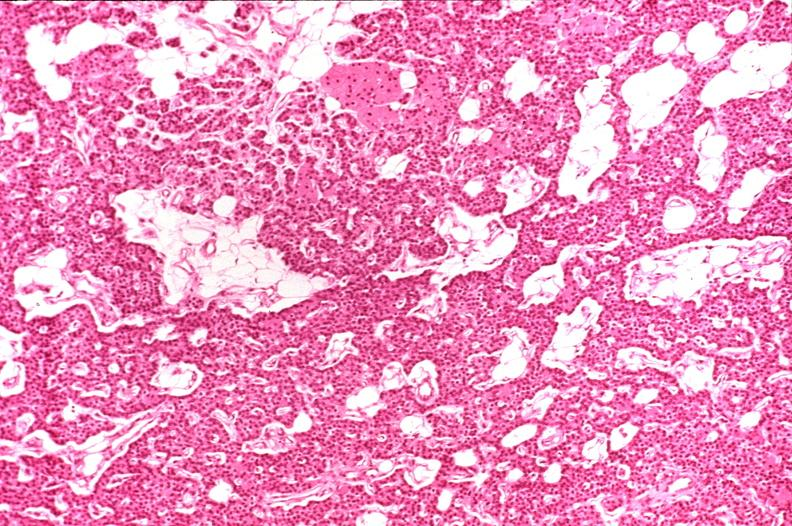what is present?
Answer the question using a single word or phrase. Endocrine 